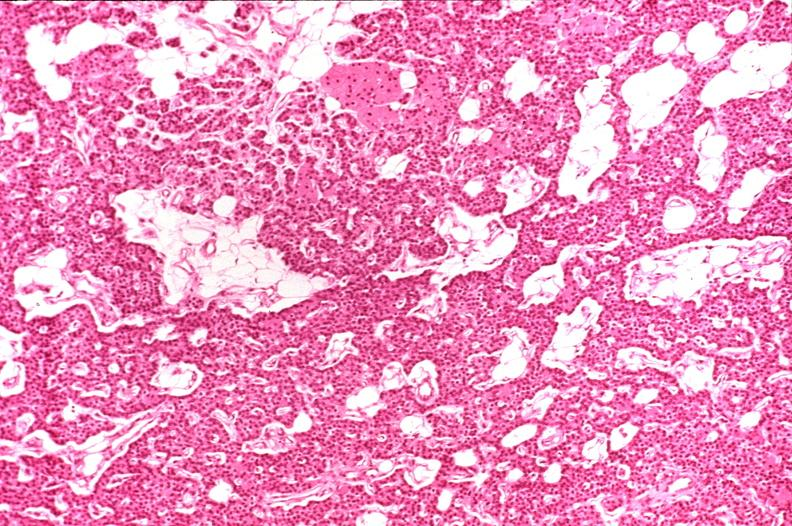what is present?
Answer the question using a single word or phrase. Endocrine 